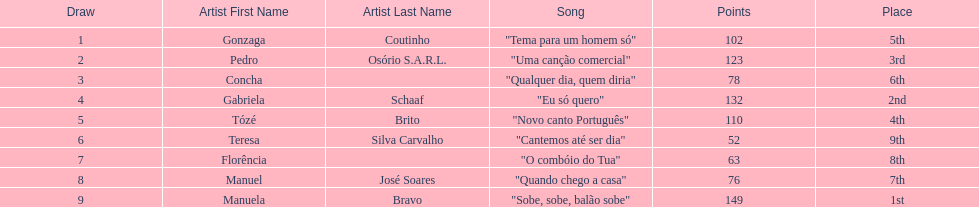Who sang "eu só quero" as their song in the eurovision song contest of 1979? Gabriela Schaaf. 